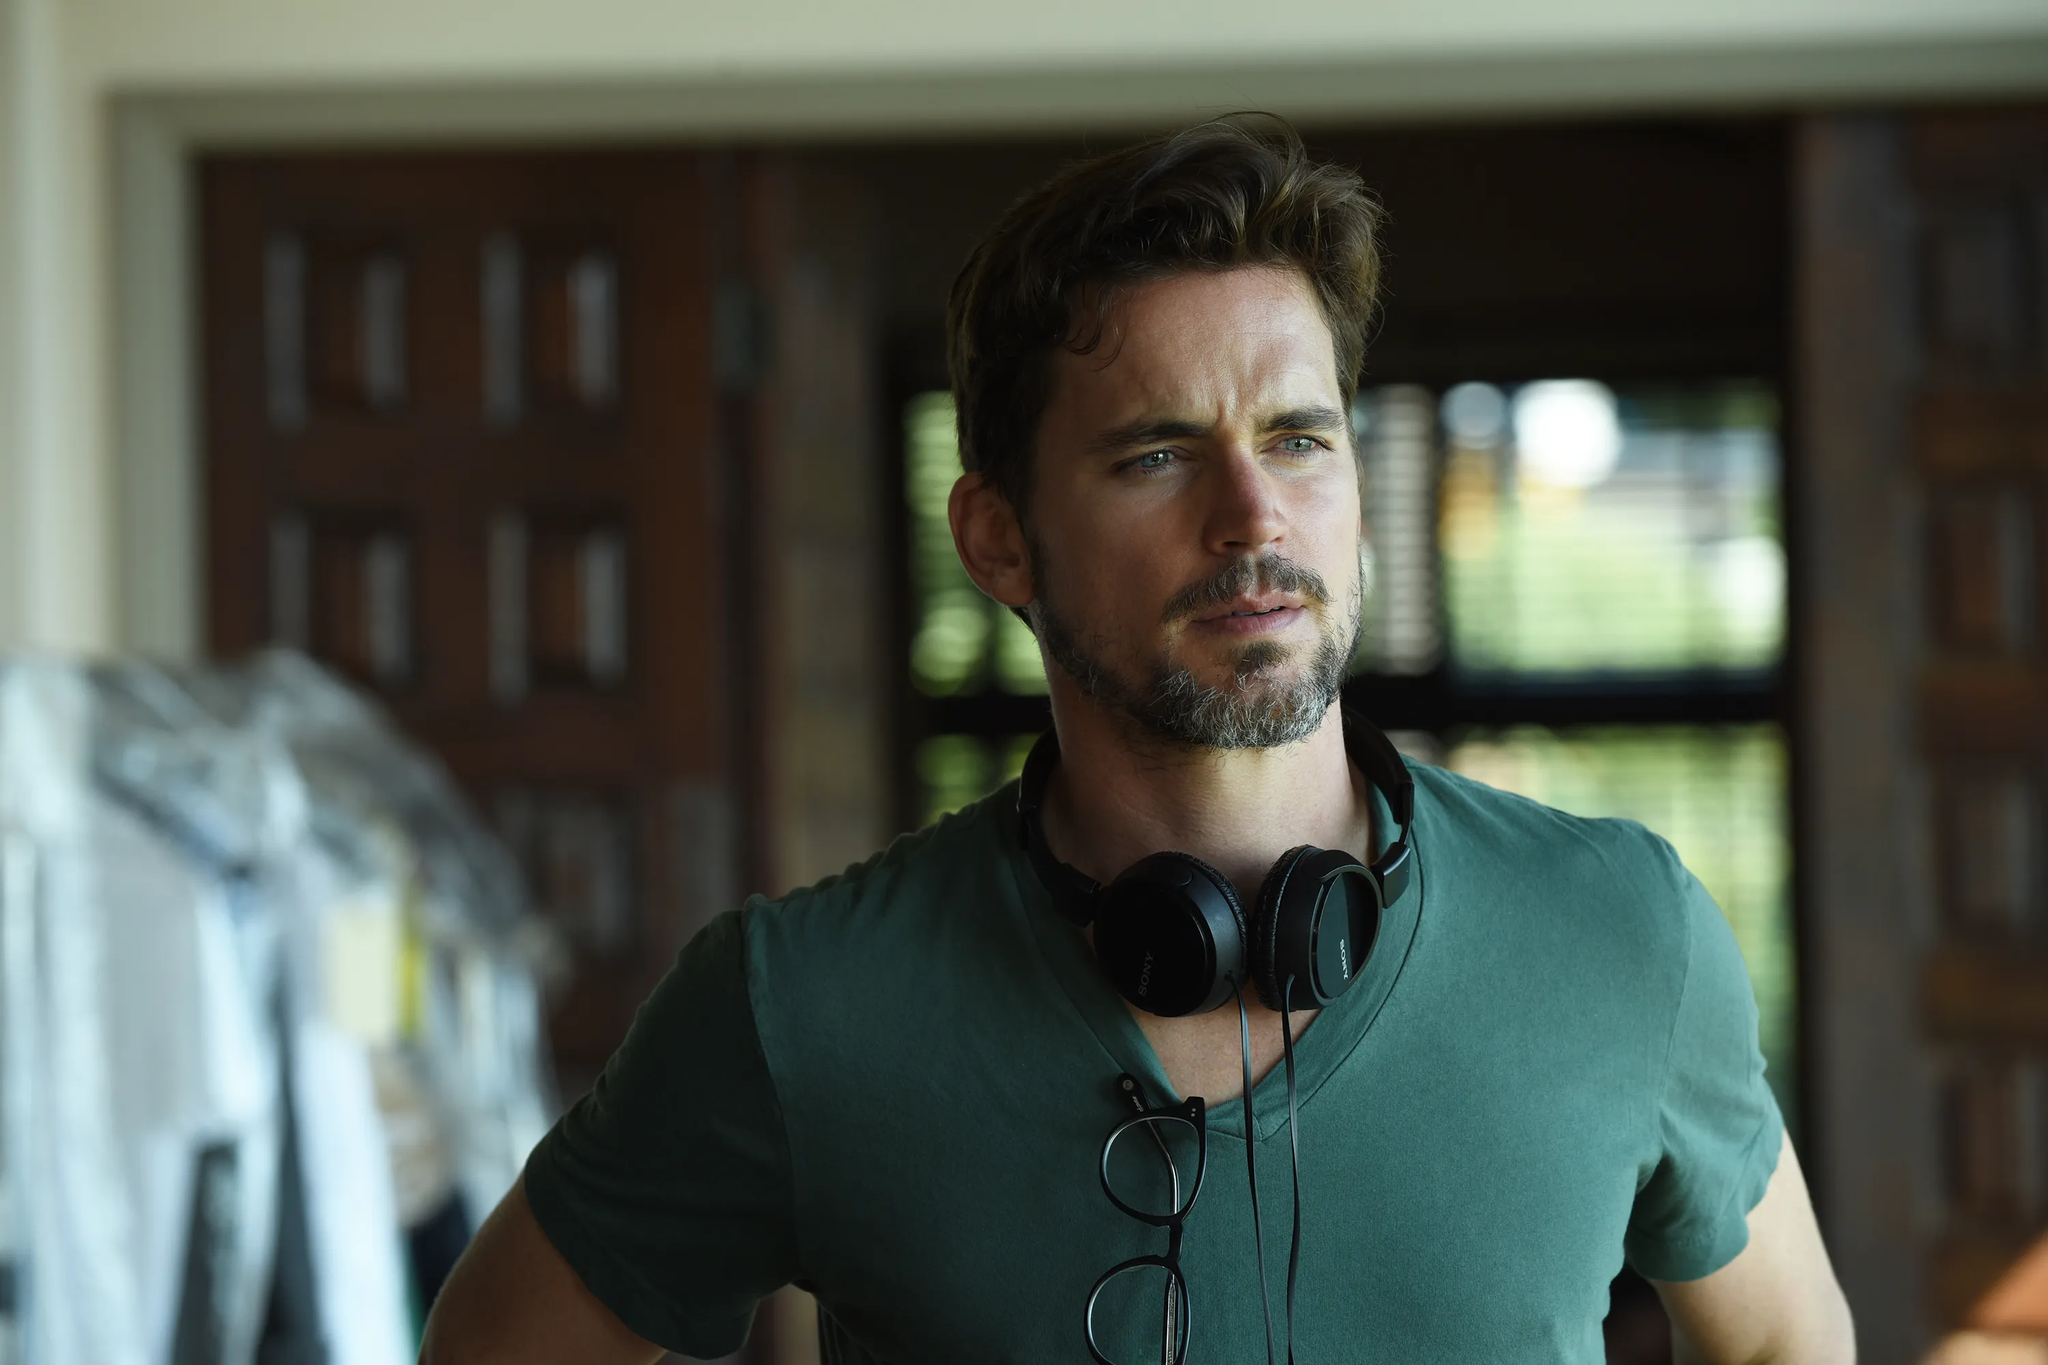Describe the following image. In the image, we see a man with striking blue eyes and neat facial hair, standing in what appears to be a room with rustic charm. The room has a wooden door and window, adding to the warm atmosphere. The man is casually dressed in a green t-shirt that complements his fair complexion. Around his neck, he has a pair of black headphones, suggesting a love for music or perhaps preparation for a role. His expression is serious and slightly contemplative as he gazes off to the side, adding an air of mystery. 